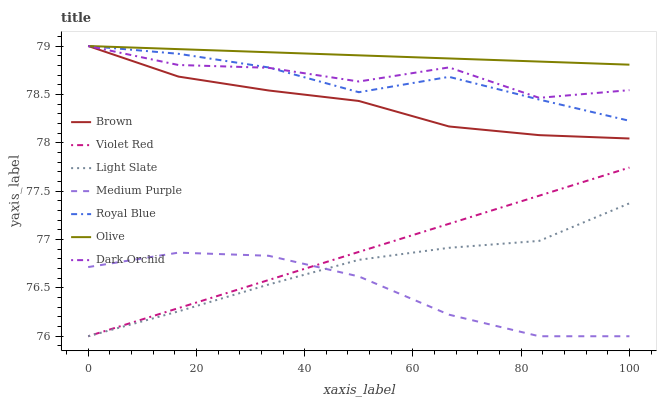Does Medium Purple have the minimum area under the curve?
Answer yes or no. Yes. Does Olive have the maximum area under the curve?
Answer yes or no. Yes. Does Violet Red have the minimum area under the curve?
Answer yes or no. No. Does Violet Red have the maximum area under the curve?
Answer yes or no. No. Is Olive the smoothest?
Answer yes or no. Yes. Is Dark Orchid the roughest?
Answer yes or no. Yes. Is Violet Red the smoothest?
Answer yes or no. No. Is Violet Red the roughest?
Answer yes or no. No. Does Violet Red have the lowest value?
Answer yes or no. Yes. Does Dark Orchid have the lowest value?
Answer yes or no. No. Does Olive have the highest value?
Answer yes or no. Yes. Does Violet Red have the highest value?
Answer yes or no. No. Is Light Slate less than Dark Orchid?
Answer yes or no. Yes. Is Royal Blue greater than Violet Red?
Answer yes or no. Yes. Does Brown intersect Dark Orchid?
Answer yes or no. Yes. Is Brown less than Dark Orchid?
Answer yes or no. No. Is Brown greater than Dark Orchid?
Answer yes or no. No. Does Light Slate intersect Dark Orchid?
Answer yes or no. No. 